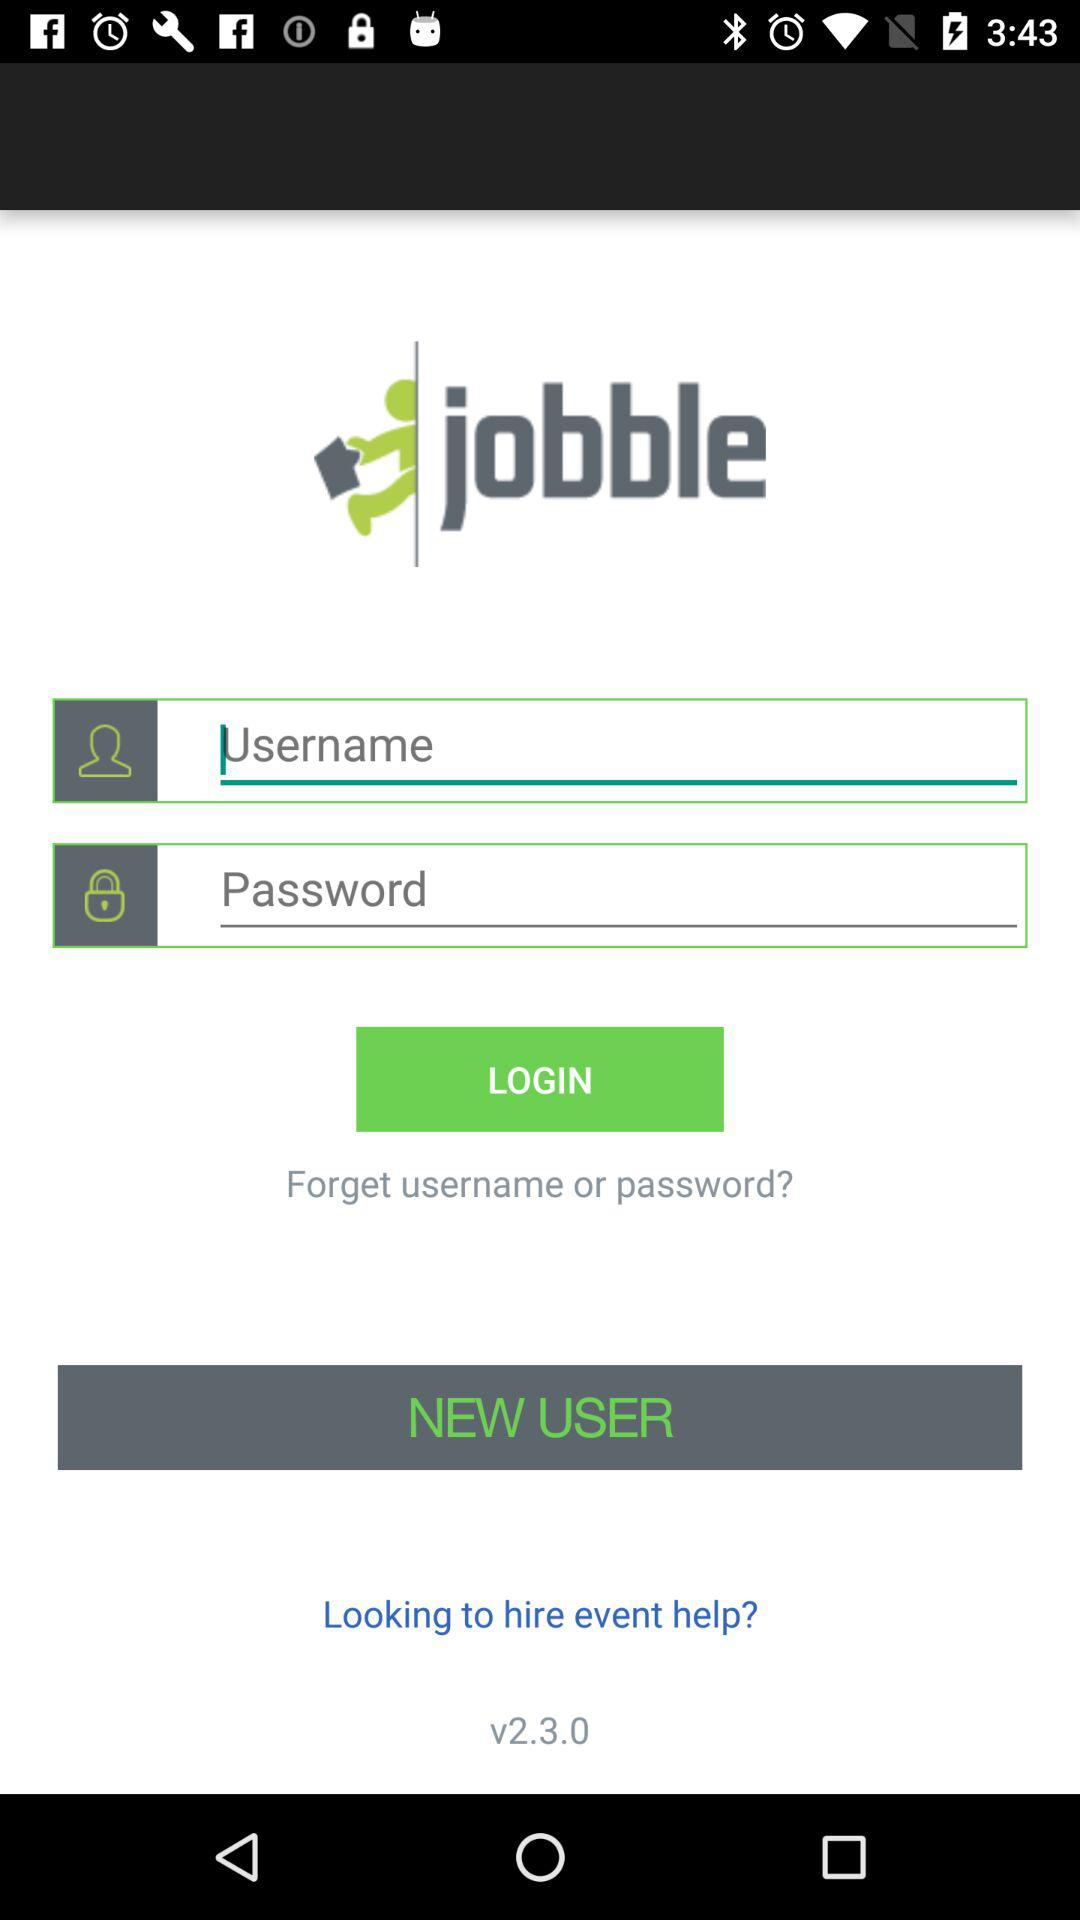What is the name of the application? The name of the application is "jobble". 